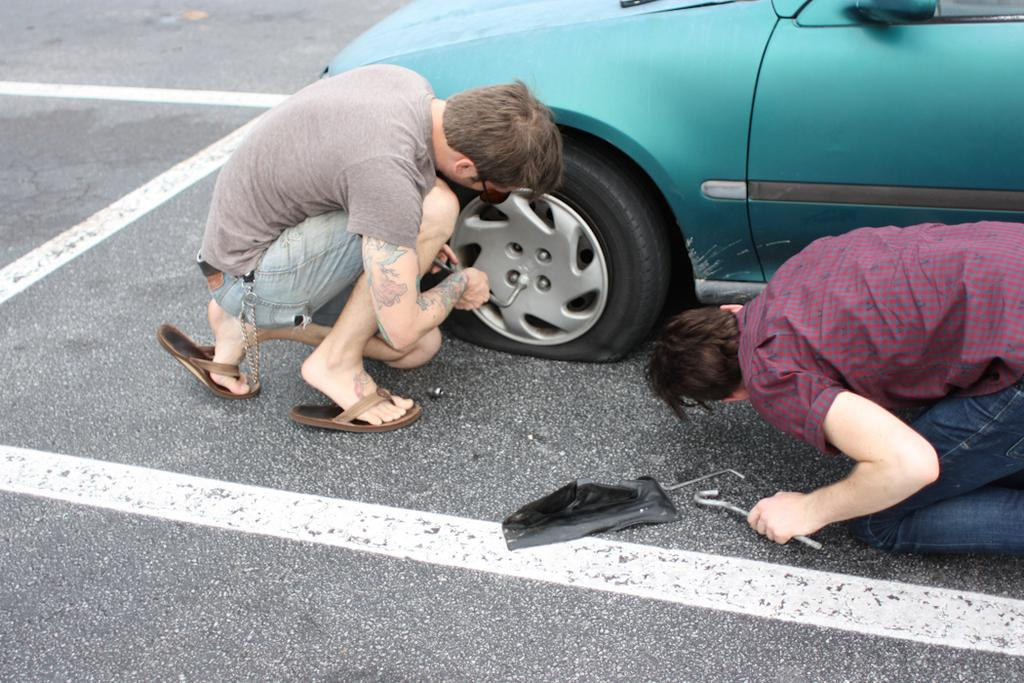How many people are in the image? There are two persons in the image. What are the persons holding in their hands? The persons are holding screws. Where are the persons sitting in the image? The persons are sitting on the floor. What can be seen in the background of the image? There is a vehicle visible in the background of the image. What type of leaf is being used by the dad in the image? There is no dad present in the image, and no leaf is visible. 